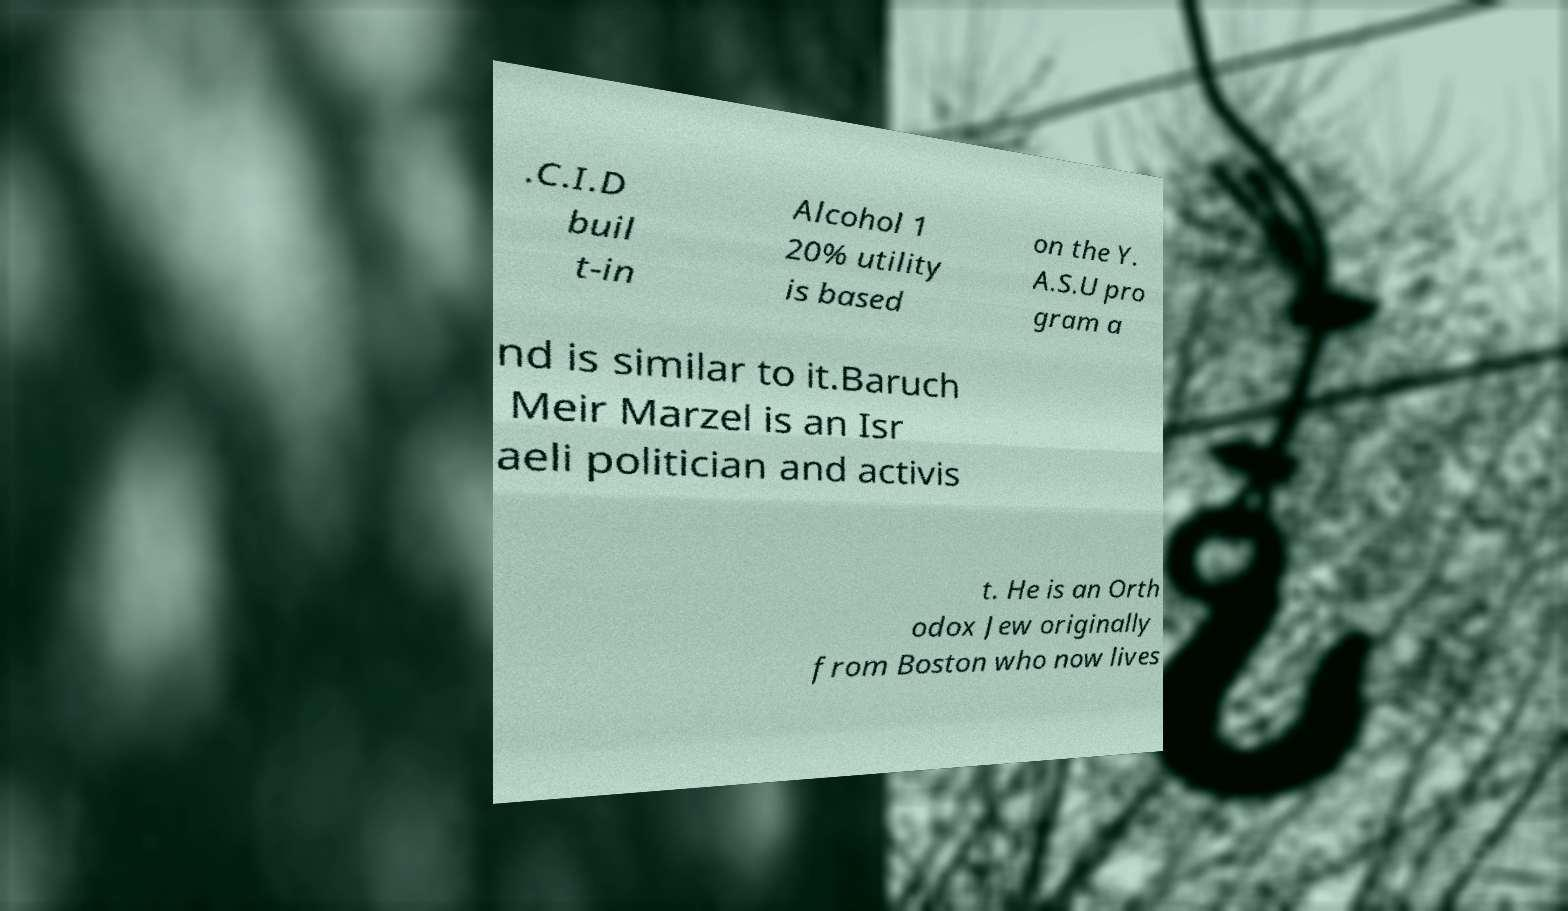Could you extract and type out the text from this image? .C.I.D buil t-in Alcohol 1 20% utility is based on the Y. A.S.U pro gram a nd is similar to it.Baruch Meir Marzel is an Isr aeli politician and activis t. He is an Orth odox Jew originally from Boston who now lives 